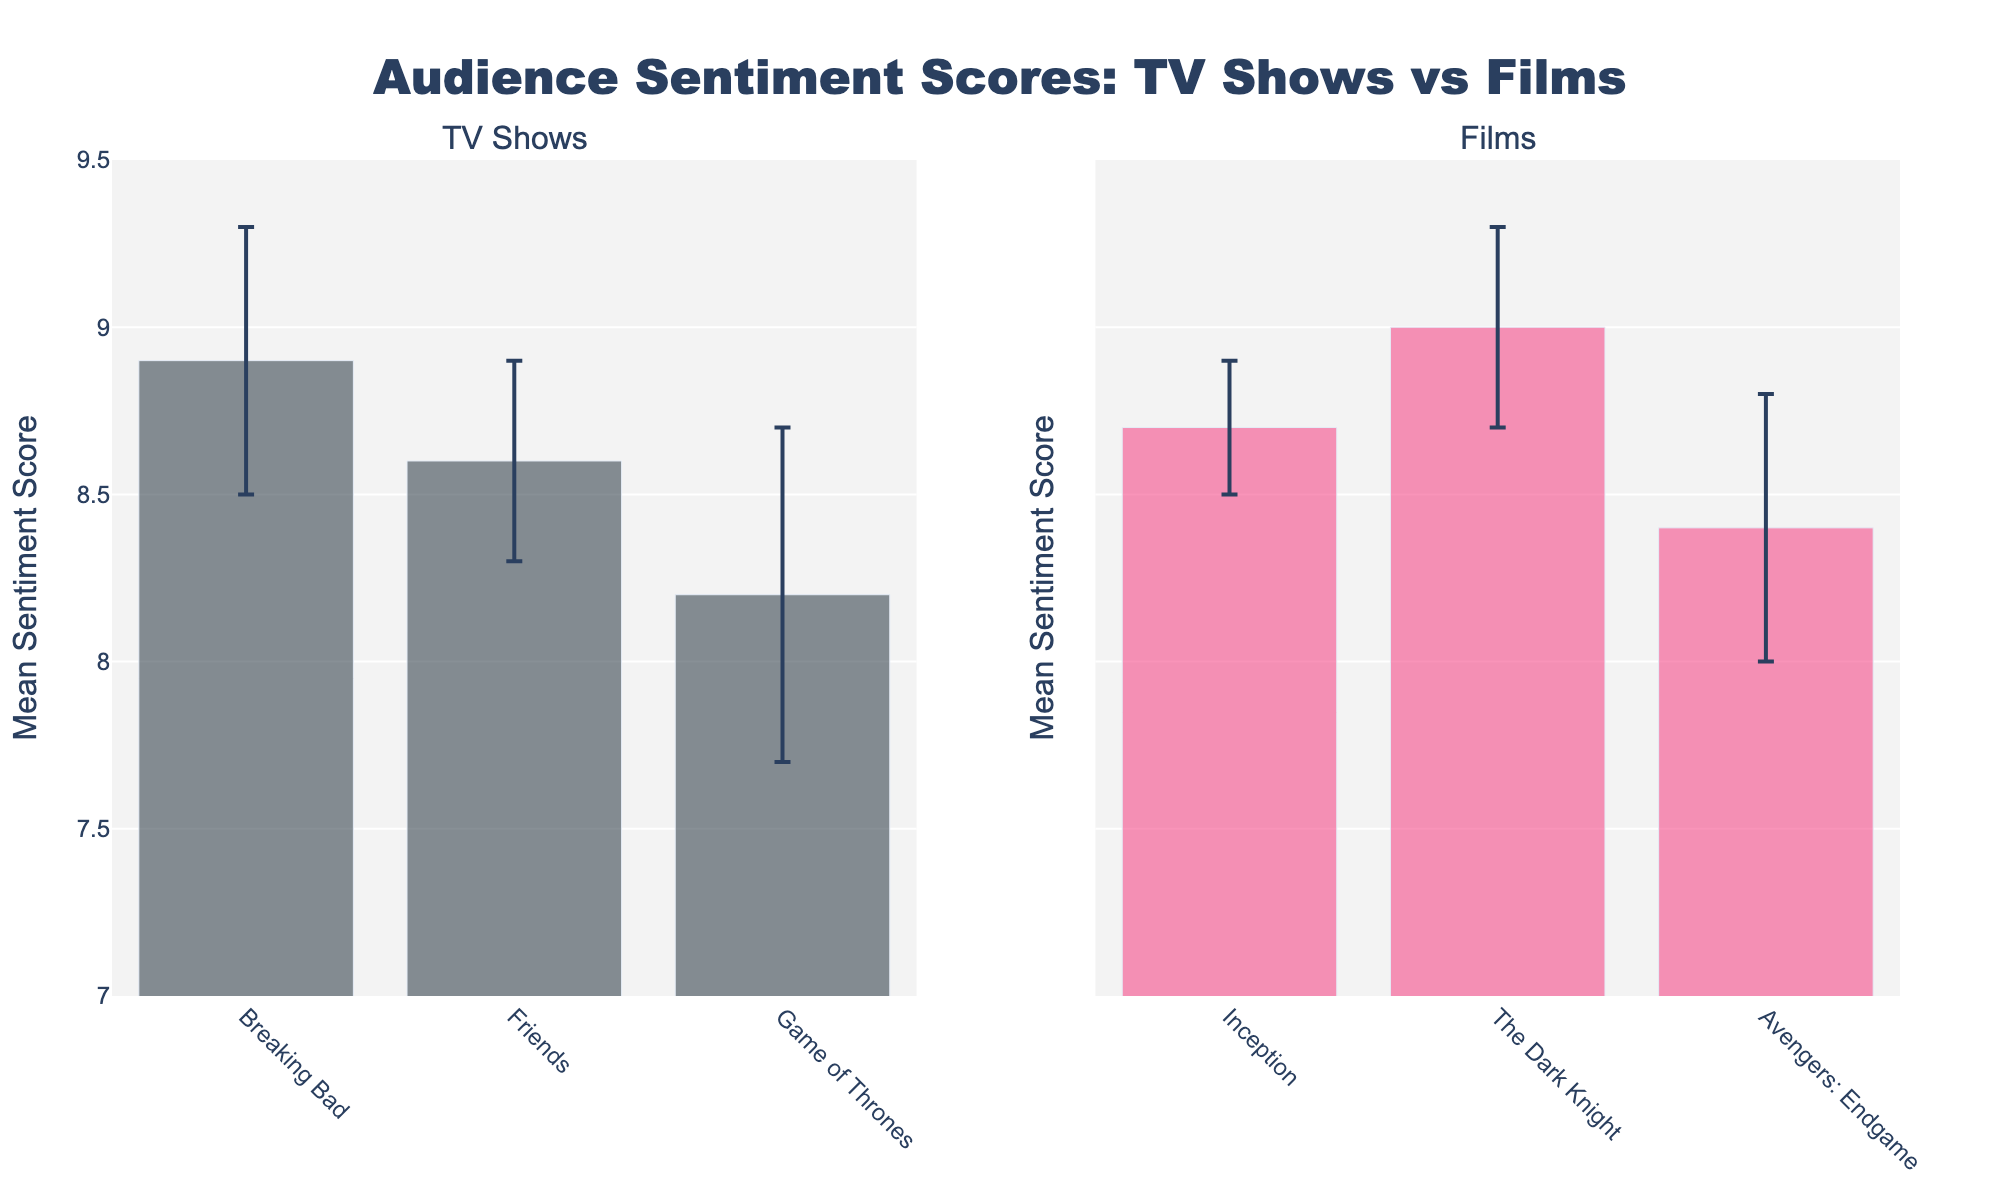what is the title of the plot? The title is usually placed at the top center of the plot. In this case, it should be clearly visible and state what the chart is about.
Answer: Audience Sentiment Scores: TV Shows vs Films what are the categories of entities present in the plot? The plot shows two main categories, usually indicated by the subplot titles or labels. Look for any text or legend that categorizes the data.
Answer: TV Shows and Films which entity has the highest mean sentiment score? To determine the highest mean sentiment score, compare the heights of the bars across all entities in both subplots.
Answer: The Dark Knight what is the mean sentiment score for 'Friends'? Locate the bar labeled "Friends" in the TV Shows subplot and read its height, which represents the mean sentiment score. It is best done by checking the y-axis corresponding to the bar height.
Answer: 8.6 what is the average mean sentiment score of the films? To calculate this, sum up the mean sentiment scores of all films and then divide by the number of films. The scores are: 8.7, 9.0, 8.4. So, (8.7 + 9.0 + 8.4) / 3 = 8.7.
Answer: 8.7 how does the standard deviation of 'Game of Thrones' compare to that of 'Breaking Bad'? Look at the length of the error bars for 'Game of Thrones' and 'Breaking Bad'. Longer error bars suggest a higher standard deviation.
Answer: 'Game of Thrones' has a higher standard deviation which show has a lower sentiment score: 'Game of Thrones' or 'Friends'? Compare the heights of the bars representing 'Game of Thrones' and 'Friends'. The lower bar indicates a lower sentiment score.
Answer: Game of Thrones by how much does 'The Dark Knight's mean sentiment score exceed 'Breaking Bad's? Subtract the mean sentiment score of 'Breaking Bad' from that of 'The Dark Knight': 9.0 - 8.9 = 0.1.
Answer: 0.1 which film has the smallest standard deviation? Identify the film with the shortest error bar in the Films subplot. The error bar length reflects the standard deviation.
Answer: Inception 